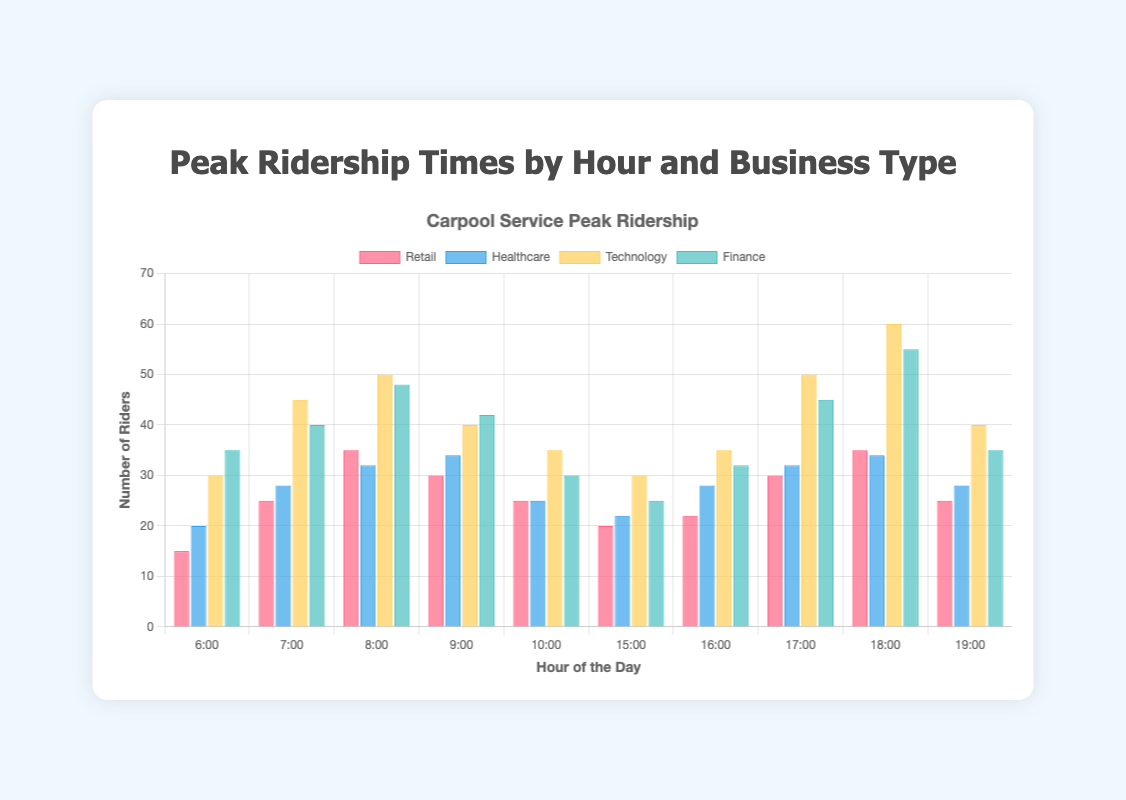What is the hour with the highest ridership for the Technology sector? Look for the bar with the greatest height in the 'Technology' dataset, which occurs during the 18:00 hour with 60 riders.
Answer: 18:00 Which sector has the lowest ridership at 7:00? Compare the heights of the bars at 7:00 across all sectors. Retail has the lowest ridership with 25 riders.
Answer: Retail What is the total ridership across all sectors at 9:00? Sum the ridership for all sectors at 9:00: Retail (30) + Healthcare (34) + Technology (40) + Finance (42) = 146.
Answer: 146 How many more riders does the Technology sector have at 18:00 compared to Retail at the same hour? Subtract the ridership of Retail from the Technology sector at 18:00: Technology (60) - Retail (35) = 25.
Answer: 25 What is the average ridership for the Healthcare sector at 8:00 and 9:00? Calculate the average by summing the values and dividing by the number of data points: (Healthcare at 8:00 = 32, Healthcare at 9:00 = 34: (32 + 34)/2 = 33.
Answer: 33 At 17:00, which sector has equal ridership to the Finance sector at 9:00? Compare the ridership data: At 17:00, Healthcare has 32 riders, which is the same as Finance's ridership of 42 at 9:00.
Answer: Healthcare Compare the ridership for Finance at 7:00 and 19:00. Which hour has more ridership, and by how much? Compare the Finance ridership at 7:00 (40) and at 19:00 (35). 7:00 has 5 more riders compared to 19:00.
Answer: 7:00, 5 What is the ratio of Technology ridership at 16:00 to Retail ridership at 10:00? Calculate the ratio of Technology ridership at 16:00 (35) to Retail at 10:00 (25): 35/25 = 1.4.
Answer: 1.4 Which hour has the second highest total ridership across all sectors, after 18:00? Calculate the total ridership for all hours and determine the second highest: 18:00 has the highest with 60+35+34+55=184 riders. 8:00 has the second highest with 35+32+50+48=165 riders.
Answer: 8:00 